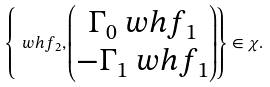Convert formula to latex. <formula><loc_0><loc_0><loc_500><loc_500>\left \{ \ w h f _ { 2 } , \begin{pmatrix} \Gamma _ { 0 } \ w h f _ { 1 } \\ - \Gamma _ { 1 } \ w h f _ { 1 } \end{pmatrix} \right \} \in \chi .</formula> 